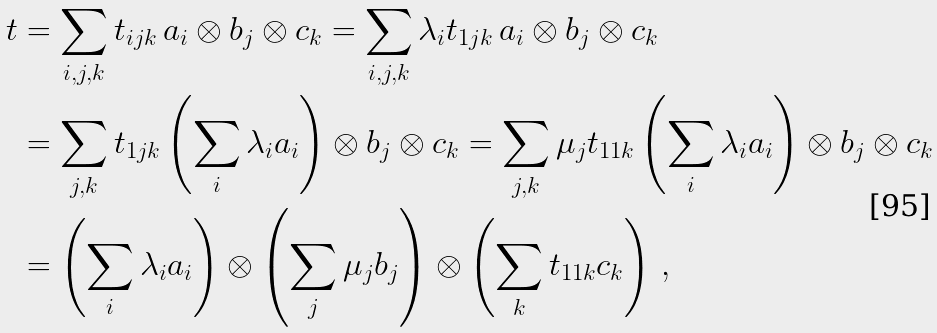Convert formula to latex. <formula><loc_0><loc_0><loc_500><loc_500>t & = \sum _ { i , j , k } t _ { i j k } \, a _ { i } \otimes b _ { j } \otimes c _ { k } = \sum _ { i , j , k } \lambda _ { i } t _ { 1 j k } \, a _ { i } \otimes b _ { j } \otimes c _ { k } \\ & = \sum _ { j , k } t _ { 1 j k } \left ( \sum _ { i } \lambda _ { i } a _ { i } \right ) \otimes b _ { j } \otimes c _ { k } = \sum _ { j , k } \mu _ { j } t _ { 1 1 k } \left ( \sum _ { i } \lambda _ { i } a _ { i } \right ) \otimes b _ { j } \otimes c _ { k } \\ & = \left ( \sum _ { i } \lambda _ { i } a _ { i } \right ) \otimes \left ( \sum _ { j } \mu _ { j } b _ { j } \right ) \otimes \left ( \sum _ { k } t _ { 1 1 k } c _ { k } \right ) \, ,</formula> 